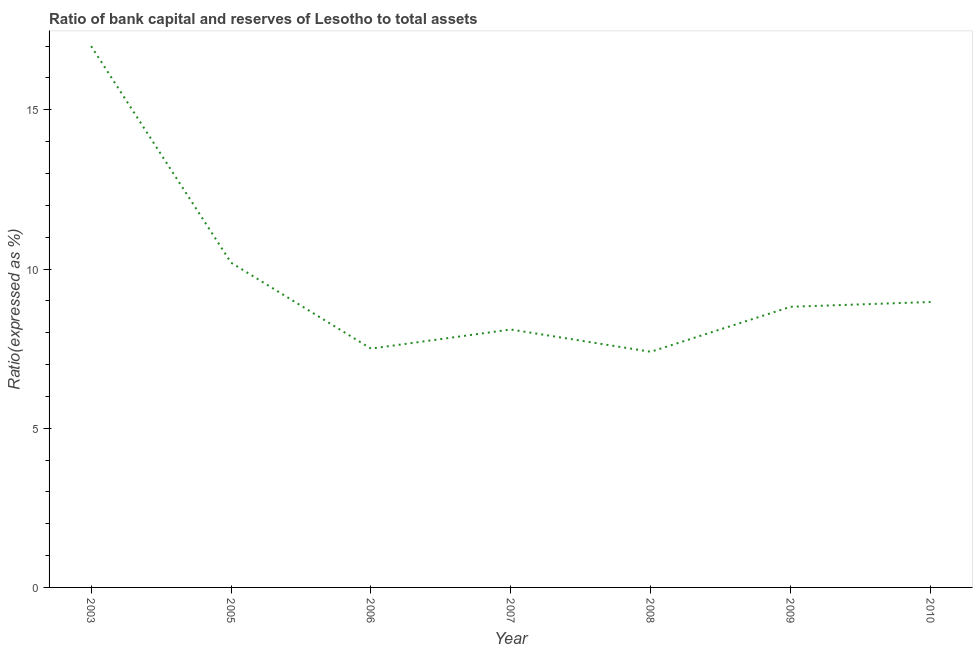Across all years, what is the maximum bank capital to assets ratio?
Give a very brief answer. 17. In which year was the bank capital to assets ratio maximum?
Your response must be concise. 2003. What is the sum of the bank capital to assets ratio?
Your answer should be very brief. 67.98. What is the difference between the bank capital to assets ratio in 2003 and 2005?
Ensure brevity in your answer.  6.8. What is the average bank capital to assets ratio per year?
Offer a terse response. 9.71. What is the median bank capital to assets ratio?
Keep it short and to the point. 8.81. In how many years, is the bank capital to assets ratio greater than 9 %?
Ensure brevity in your answer.  2. What is the ratio of the bank capital to assets ratio in 2005 to that in 2008?
Your answer should be very brief. 1.38. What is the difference between the highest and the second highest bank capital to assets ratio?
Your answer should be very brief. 6.8. Is the sum of the bank capital to assets ratio in 2003 and 2008 greater than the maximum bank capital to assets ratio across all years?
Your response must be concise. Yes. In how many years, is the bank capital to assets ratio greater than the average bank capital to assets ratio taken over all years?
Offer a very short reply. 2. Does the bank capital to assets ratio monotonically increase over the years?
Provide a succinct answer. No. How many years are there in the graph?
Make the answer very short. 7. Are the values on the major ticks of Y-axis written in scientific E-notation?
Give a very brief answer. No. Does the graph contain any zero values?
Provide a succinct answer. No. Does the graph contain grids?
Offer a very short reply. No. What is the title of the graph?
Your response must be concise. Ratio of bank capital and reserves of Lesotho to total assets. What is the label or title of the X-axis?
Offer a very short reply. Year. What is the label or title of the Y-axis?
Your answer should be compact. Ratio(expressed as %). What is the Ratio(expressed as %) in 2005?
Make the answer very short. 10.2. What is the Ratio(expressed as %) of 2009?
Provide a succinct answer. 8.81. What is the Ratio(expressed as %) of 2010?
Give a very brief answer. 8.96. What is the difference between the Ratio(expressed as %) in 2003 and 2005?
Keep it short and to the point. 6.8. What is the difference between the Ratio(expressed as %) in 2003 and 2006?
Provide a succinct answer. 9.5. What is the difference between the Ratio(expressed as %) in 2003 and 2007?
Your answer should be very brief. 8.9. What is the difference between the Ratio(expressed as %) in 2003 and 2009?
Ensure brevity in your answer.  8.19. What is the difference between the Ratio(expressed as %) in 2003 and 2010?
Your answer should be compact. 8.04. What is the difference between the Ratio(expressed as %) in 2005 and 2006?
Provide a succinct answer. 2.7. What is the difference between the Ratio(expressed as %) in 2005 and 2007?
Your response must be concise. 2.1. What is the difference between the Ratio(expressed as %) in 2005 and 2009?
Offer a terse response. 1.39. What is the difference between the Ratio(expressed as %) in 2005 and 2010?
Give a very brief answer. 1.24. What is the difference between the Ratio(expressed as %) in 2006 and 2007?
Offer a very short reply. -0.6. What is the difference between the Ratio(expressed as %) in 2006 and 2008?
Your response must be concise. 0.1. What is the difference between the Ratio(expressed as %) in 2006 and 2009?
Your answer should be very brief. -1.31. What is the difference between the Ratio(expressed as %) in 2006 and 2010?
Give a very brief answer. -1.46. What is the difference between the Ratio(expressed as %) in 2007 and 2009?
Offer a very short reply. -0.71. What is the difference between the Ratio(expressed as %) in 2007 and 2010?
Offer a terse response. -0.86. What is the difference between the Ratio(expressed as %) in 2008 and 2009?
Your response must be concise. -1.41. What is the difference between the Ratio(expressed as %) in 2008 and 2010?
Ensure brevity in your answer.  -1.56. What is the difference between the Ratio(expressed as %) in 2009 and 2010?
Offer a terse response. -0.15. What is the ratio of the Ratio(expressed as %) in 2003 to that in 2005?
Provide a short and direct response. 1.67. What is the ratio of the Ratio(expressed as %) in 2003 to that in 2006?
Offer a terse response. 2.27. What is the ratio of the Ratio(expressed as %) in 2003 to that in 2007?
Offer a very short reply. 2.1. What is the ratio of the Ratio(expressed as %) in 2003 to that in 2008?
Provide a short and direct response. 2.3. What is the ratio of the Ratio(expressed as %) in 2003 to that in 2009?
Offer a very short reply. 1.93. What is the ratio of the Ratio(expressed as %) in 2003 to that in 2010?
Offer a very short reply. 1.9. What is the ratio of the Ratio(expressed as %) in 2005 to that in 2006?
Provide a succinct answer. 1.36. What is the ratio of the Ratio(expressed as %) in 2005 to that in 2007?
Give a very brief answer. 1.26. What is the ratio of the Ratio(expressed as %) in 2005 to that in 2008?
Keep it short and to the point. 1.38. What is the ratio of the Ratio(expressed as %) in 2005 to that in 2009?
Provide a short and direct response. 1.16. What is the ratio of the Ratio(expressed as %) in 2005 to that in 2010?
Offer a terse response. 1.14. What is the ratio of the Ratio(expressed as %) in 2006 to that in 2007?
Make the answer very short. 0.93. What is the ratio of the Ratio(expressed as %) in 2006 to that in 2008?
Your answer should be compact. 1.01. What is the ratio of the Ratio(expressed as %) in 2006 to that in 2009?
Your answer should be compact. 0.85. What is the ratio of the Ratio(expressed as %) in 2006 to that in 2010?
Provide a succinct answer. 0.84. What is the ratio of the Ratio(expressed as %) in 2007 to that in 2008?
Provide a succinct answer. 1.09. What is the ratio of the Ratio(expressed as %) in 2007 to that in 2009?
Make the answer very short. 0.92. What is the ratio of the Ratio(expressed as %) in 2007 to that in 2010?
Provide a short and direct response. 0.9. What is the ratio of the Ratio(expressed as %) in 2008 to that in 2009?
Make the answer very short. 0.84. What is the ratio of the Ratio(expressed as %) in 2008 to that in 2010?
Make the answer very short. 0.83. 